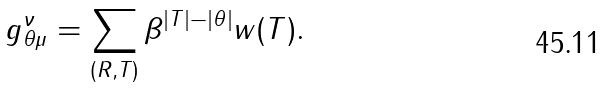<formula> <loc_0><loc_0><loc_500><loc_500>g _ { \theta \mu } ^ { \nu } = \sum _ { ( R , T ) } \beta ^ { | T | - | \theta | } w ( T ) .</formula> 